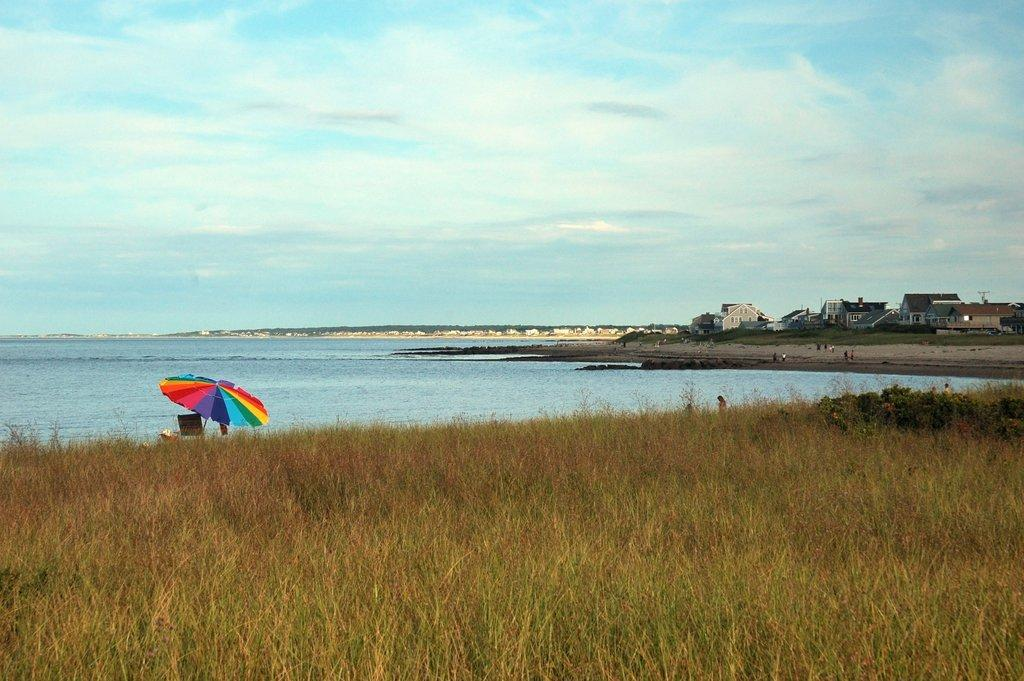What type of vegetation can be seen in the image? There is grass in the image. What object is present to provide shade? There is an umbrella in the image. What type of furniture is visible in the image? There is a chair in the image. Can you describe the people visible in the distance? People are visible in the distance, but their specific features cannot be discerned from the image. What natural element is visible in the image? There is water visible in the image. What type of structures can be seen in the background of the image? There are buildings in the background of the image. What is visible in the sky in the image? The sky is visible in the background of the image, and clouds are present. What type of paste is being used to create the plantation in the image? There is no plantation or paste present in the image; it features grass, an umbrella, a chair, people in the distance, water, buildings, and a sky with clouds. 